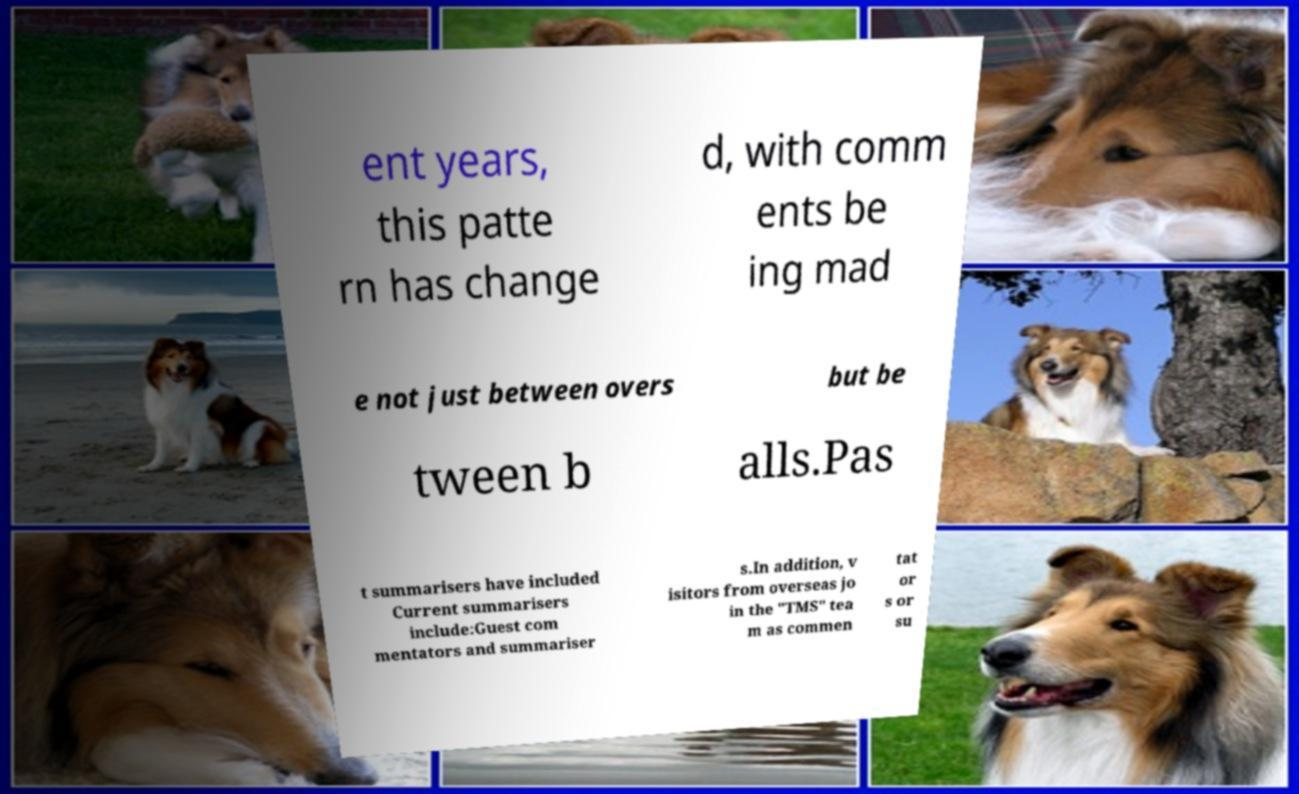What messages or text are displayed in this image? I need them in a readable, typed format. ent years, this patte rn has change d, with comm ents be ing mad e not just between overs but be tween b alls.Pas t summarisers have included Current summarisers include:Guest com mentators and summariser s.In addition, v isitors from overseas jo in the "TMS" tea m as commen tat or s or su 